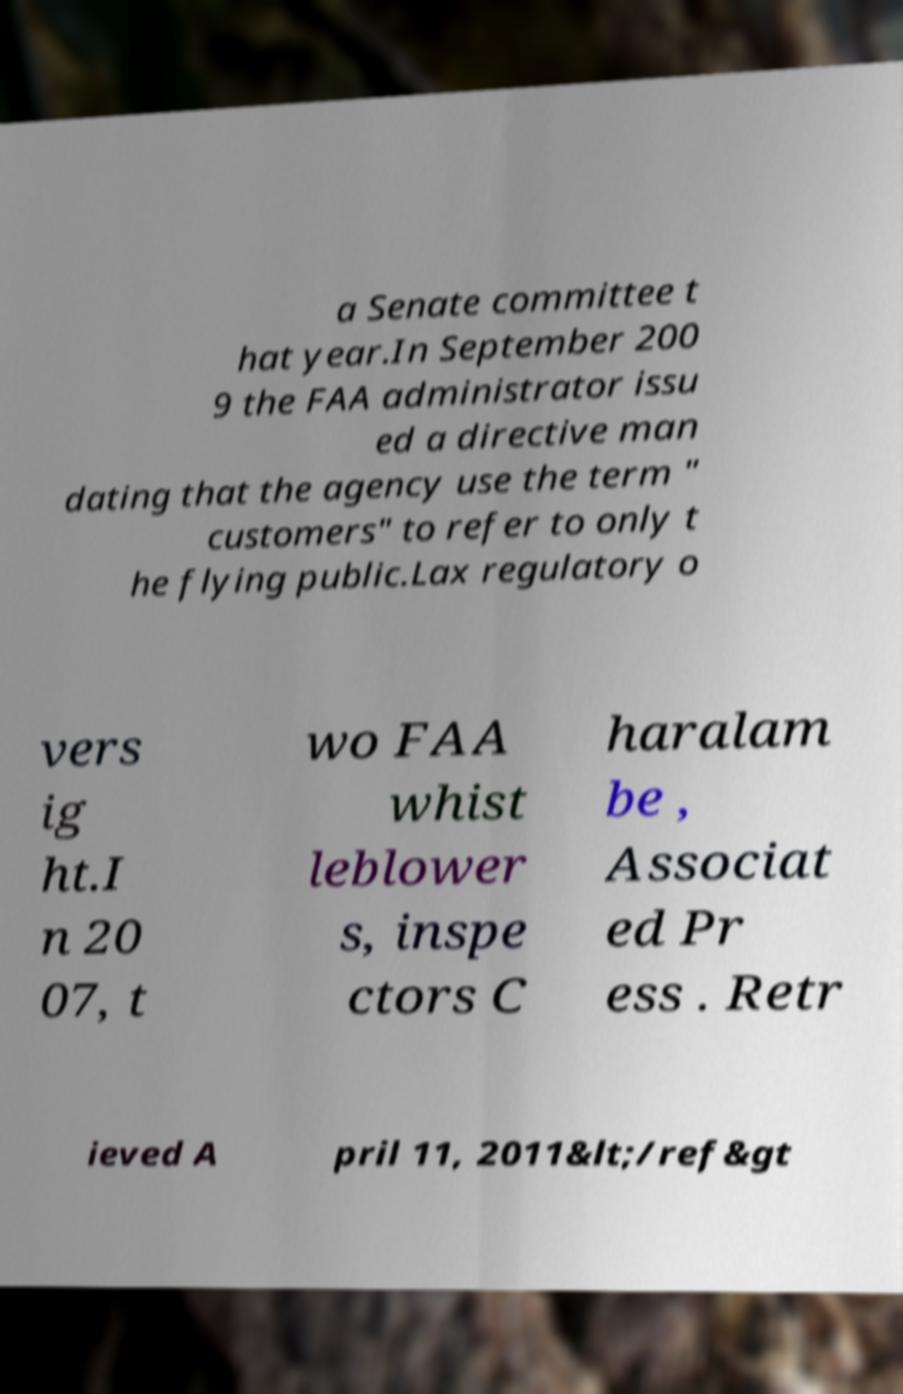Please identify and transcribe the text found in this image. a Senate committee t hat year.In September 200 9 the FAA administrator issu ed a directive man dating that the agency use the term " customers" to refer to only t he flying public.Lax regulatory o vers ig ht.I n 20 07, t wo FAA whist leblower s, inspe ctors C haralam be , Associat ed Pr ess . Retr ieved A pril 11, 2011&lt;/ref&gt 